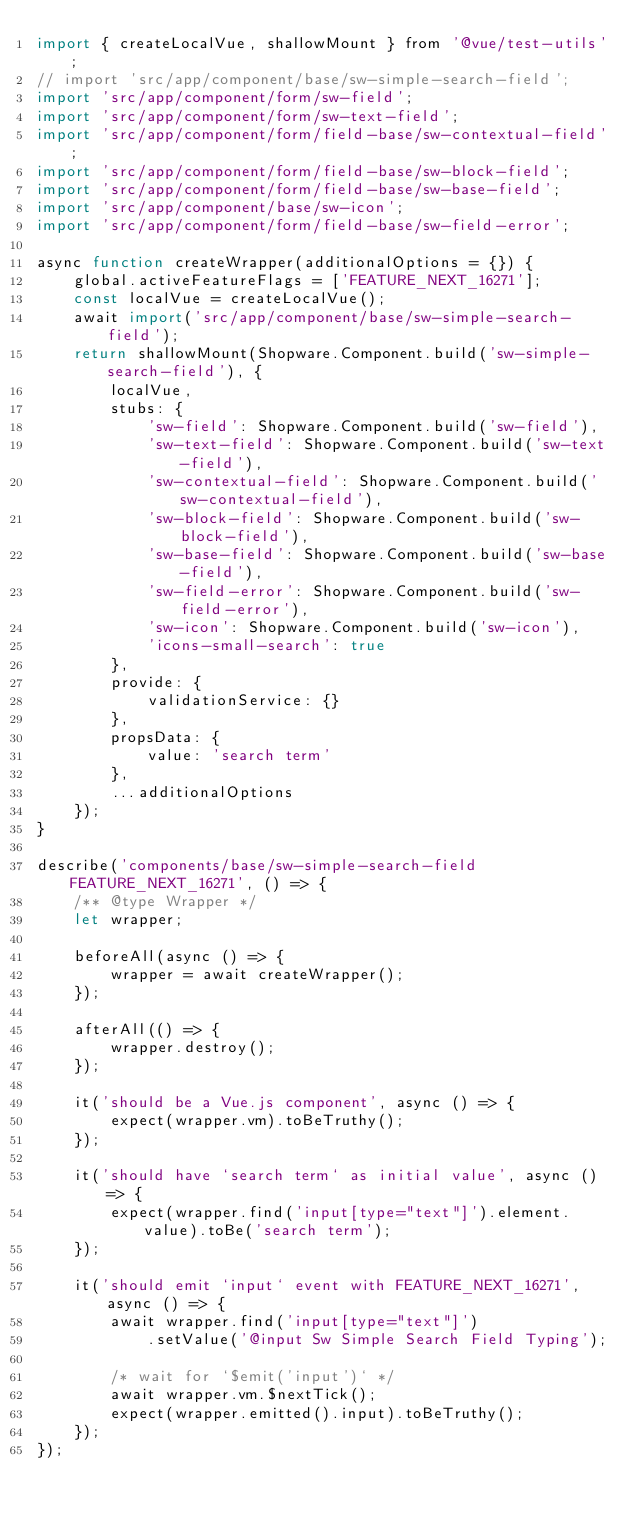Convert code to text. <code><loc_0><loc_0><loc_500><loc_500><_JavaScript_>import { createLocalVue, shallowMount } from '@vue/test-utils';
// import 'src/app/component/base/sw-simple-search-field';
import 'src/app/component/form/sw-field';
import 'src/app/component/form/sw-text-field';
import 'src/app/component/form/field-base/sw-contextual-field';
import 'src/app/component/form/field-base/sw-block-field';
import 'src/app/component/form/field-base/sw-base-field';
import 'src/app/component/base/sw-icon';
import 'src/app/component/form/field-base/sw-field-error';

async function createWrapper(additionalOptions = {}) {
    global.activeFeatureFlags = ['FEATURE_NEXT_16271'];
    const localVue = createLocalVue();
    await import('src/app/component/base/sw-simple-search-field');
    return shallowMount(Shopware.Component.build('sw-simple-search-field'), {
        localVue,
        stubs: {
            'sw-field': Shopware.Component.build('sw-field'),
            'sw-text-field': Shopware.Component.build('sw-text-field'),
            'sw-contextual-field': Shopware.Component.build('sw-contextual-field'),
            'sw-block-field': Shopware.Component.build('sw-block-field'),
            'sw-base-field': Shopware.Component.build('sw-base-field'),
            'sw-field-error': Shopware.Component.build('sw-field-error'),
            'sw-icon': Shopware.Component.build('sw-icon'),
            'icons-small-search': true
        },
        provide: {
            validationService: {}
        },
        propsData: {
            value: 'search term'
        },
        ...additionalOptions
    });
}

describe('components/base/sw-simple-search-field FEATURE_NEXT_16271', () => {
    /** @type Wrapper */
    let wrapper;

    beforeAll(async () => {
        wrapper = await createWrapper();
    });

    afterAll(() => {
        wrapper.destroy();
    });

    it('should be a Vue.js component', async () => {
        expect(wrapper.vm).toBeTruthy();
    });

    it('should have `search term` as initial value', async () => {
        expect(wrapper.find('input[type="text"]').element.value).toBe('search term');
    });

    it('should emit `input` event with FEATURE_NEXT_16271', async () => {
        await wrapper.find('input[type="text"]')
            .setValue('@input Sw Simple Search Field Typing');

        /* wait for `$emit('input')` */
        await wrapper.vm.$nextTick();
        expect(wrapper.emitted().input).toBeTruthy();
    });
});
</code> 